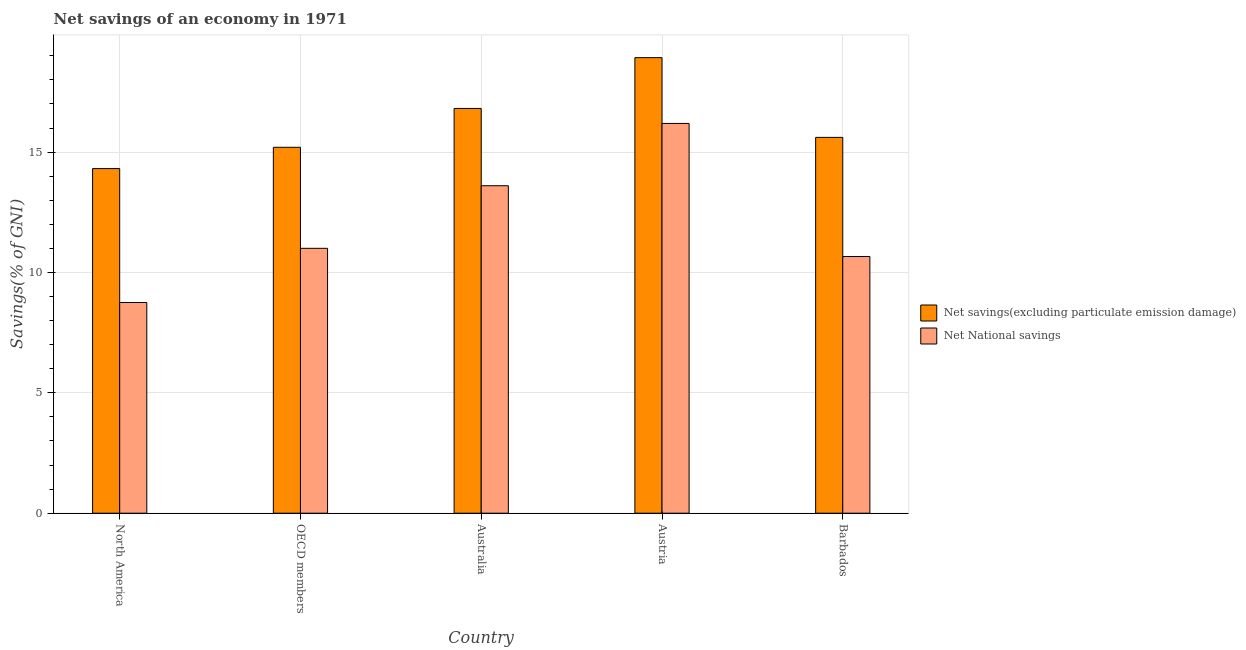How many different coloured bars are there?
Your answer should be very brief. 2. How many bars are there on the 5th tick from the left?
Offer a terse response. 2. How many bars are there on the 3rd tick from the right?
Keep it short and to the point. 2. In how many cases, is the number of bars for a given country not equal to the number of legend labels?
Offer a very short reply. 0. What is the net savings(excluding particulate emission damage) in Austria?
Provide a short and direct response. 18.92. Across all countries, what is the maximum net savings(excluding particulate emission damage)?
Keep it short and to the point. 18.92. Across all countries, what is the minimum net savings(excluding particulate emission damage)?
Your response must be concise. 14.31. In which country was the net savings(excluding particulate emission damage) maximum?
Keep it short and to the point. Austria. What is the total net savings(excluding particulate emission damage) in the graph?
Your answer should be compact. 80.86. What is the difference between the net national savings in Austria and that in Barbados?
Give a very brief answer. 5.53. What is the difference between the net savings(excluding particulate emission damage) in Australia and the net national savings in Barbados?
Offer a terse response. 6.15. What is the average net national savings per country?
Offer a terse response. 12.04. What is the difference between the net national savings and net savings(excluding particulate emission damage) in Austria?
Keep it short and to the point. -2.73. In how many countries, is the net national savings greater than 18 %?
Your answer should be very brief. 0. What is the ratio of the net national savings in Australia to that in OECD members?
Your response must be concise. 1.24. What is the difference between the highest and the second highest net national savings?
Your answer should be compact. 2.59. What is the difference between the highest and the lowest net national savings?
Make the answer very short. 7.44. In how many countries, is the net savings(excluding particulate emission damage) greater than the average net savings(excluding particulate emission damage) taken over all countries?
Your response must be concise. 2. What does the 1st bar from the left in North America represents?
Your response must be concise. Net savings(excluding particulate emission damage). What does the 1st bar from the right in Barbados represents?
Your answer should be compact. Net National savings. How many bars are there?
Your response must be concise. 10. How many countries are there in the graph?
Provide a succinct answer. 5. How are the legend labels stacked?
Offer a terse response. Vertical. What is the title of the graph?
Offer a very short reply. Net savings of an economy in 1971. What is the label or title of the X-axis?
Provide a short and direct response. Country. What is the label or title of the Y-axis?
Provide a short and direct response. Savings(% of GNI). What is the Savings(% of GNI) of Net savings(excluding particulate emission damage) in North America?
Give a very brief answer. 14.31. What is the Savings(% of GNI) of Net National savings in North America?
Ensure brevity in your answer.  8.75. What is the Savings(% of GNI) in Net savings(excluding particulate emission damage) in OECD members?
Keep it short and to the point. 15.2. What is the Savings(% of GNI) in Net National savings in OECD members?
Your response must be concise. 11. What is the Savings(% of GNI) in Net savings(excluding particulate emission damage) in Australia?
Your answer should be very brief. 16.81. What is the Savings(% of GNI) of Net National savings in Australia?
Ensure brevity in your answer.  13.6. What is the Savings(% of GNI) of Net savings(excluding particulate emission damage) in Austria?
Ensure brevity in your answer.  18.92. What is the Savings(% of GNI) in Net National savings in Austria?
Your response must be concise. 16.19. What is the Savings(% of GNI) in Net savings(excluding particulate emission damage) in Barbados?
Your answer should be very brief. 15.61. What is the Savings(% of GNI) of Net National savings in Barbados?
Keep it short and to the point. 10.66. Across all countries, what is the maximum Savings(% of GNI) in Net savings(excluding particulate emission damage)?
Ensure brevity in your answer.  18.92. Across all countries, what is the maximum Savings(% of GNI) of Net National savings?
Offer a very short reply. 16.19. Across all countries, what is the minimum Savings(% of GNI) in Net savings(excluding particulate emission damage)?
Make the answer very short. 14.31. Across all countries, what is the minimum Savings(% of GNI) of Net National savings?
Provide a succinct answer. 8.75. What is the total Savings(% of GNI) in Net savings(excluding particulate emission damage) in the graph?
Your answer should be compact. 80.86. What is the total Savings(% of GNI) of Net National savings in the graph?
Your response must be concise. 60.21. What is the difference between the Savings(% of GNI) of Net savings(excluding particulate emission damage) in North America and that in OECD members?
Provide a short and direct response. -0.88. What is the difference between the Savings(% of GNI) in Net National savings in North America and that in OECD members?
Give a very brief answer. -2.25. What is the difference between the Savings(% of GNI) in Net savings(excluding particulate emission damage) in North America and that in Australia?
Give a very brief answer. -2.5. What is the difference between the Savings(% of GNI) of Net National savings in North America and that in Australia?
Offer a very short reply. -4.85. What is the difference between the Savings(% of GNI) of Net savings(excluding particulate emission damage) in North America and that in Austria?
Provide a short and direct response. -4.61. What is the difference between the Savings(% of GNI) of Net National savings in North America and that in Austria?
Make the answer very short. -7.44. What is the difference between the Savings(% of GNI) in Net savings(excluding particulate emission damage) in North America and that in Barbados?
Offer a terse response. -1.3. What is the difference between the Savings(% of GNI) in Net National savings in North America and that in Barbados?
Make the answer very short. -1.91. What is the difference between the Savings(% of GNI) of Net savings(excluding particulate emission damage) in OECD members and that in Australia?
Keep it short and to the point. -1.61. What is the difference between the Savings(% of GNI) of Net savings(excluding particulate emission damage) in OECD members and that in Austria?
Keep it short and to the point. -3.72. What is the difference between the Savings(% of GNI) of Net National savings in OECD members and that in Austria?
Give a very brief answer. -5.19. What is the difference between the Savings(% of GNI) of Net savings(excluding particulate emission damage) in OECD members and that in Barbados?
Provide a short and direct response. -0.41. What is the difference between the Savings(% of GNI) of Net National savings in OECD members and that in Barbados?
Make the answer very short. 0.34. What is the difference between the Savings(% of GNI) of Net savings(excluding particulate emission damage) in Australia and that in Austria?
Make the answer very short. -2.11. What is the difference between the Savings(% of GNI) in Net National savings in Australia and that in Austria?
Offer a very short reply. -2.59. What is the difference between the Savings(% of GNI) in Net savings(excluding particulate emission damage) in Australia and that in Barbados?
Your answer should be very brief. 1.2. What is the difference between the Savings(% of GNI) in Net National savings in Australia and that in Barbados?
Your answer should be very brief. 2.94. What is the difference between the Savings(% of GNI) in Net savings(excluding particulate emission damage) in Austria and that in Barbados?
Offer a very short reply. 3.31. What is the difference between the Savings(% of GNI) in Net National savings in Austria and that in Barbados?
Your answer should be compact. 5.53. What is the difference between the Savings(% of GNI) in Net savings(excluding particulate emission damage) in North America and the Savings(% of GNI) in Net National savings in OECD members?
Your response must be concise. 3.31. What is the difference between the Savings(% of GNI) in Net savings(excluding particulate emission damage) in North America and the Savings(% of GNI) in Net National savings in Australia?
Your answer should be compact. 0.71. What is the difference between the Savings(% of GNI) in Net savings(excluding particulate emission damage) in North America and the Savings(% of GNI) in Net National savings in Austria?
Your response must be concise. -1.88. What is the difference between the Savings(% of GNI) of Net savings(excluding particulate emission damage) in North America and the Savings(% of GNI) of Net National savings in Barbados?
Your answer should be very brief. 3.65. What is the difference between the Savings(% of GNI) in Net savings(excluding particulate emission damage) in OECD members and the Savings(% of GNI) in Net National savings in Australia?
Keep it short and to the point. 1.6. What is the difference between the Savings(% of GNI) of Net savings(excluding particulate emission damage) in OECD members and the Savings(% of GNI) of Net National savings in Austria?
Give a very brief answer. -0.99. What is the difference between the Savings(% of GNI) of Net savings(excluding particulate emission damage) in OECD members and the Savings(% of GNI) of Net National savings in Barbados?
Your answer should be compact. 4.54. What is the difference between the Savings(% of GNI) in Net savings(excluding particulate emission damage) in Australia and the Savings(% of GNI) in Net National savings in Austria?
Make the answer very short. 0.62. What is the difference between the Savings(% of GNI) of Net savings(excluding particulate emission damage) in Australia and the Savings(% of GNI) of Net National savings in Barbados?
Give a very brief answer. 6.15. What is the difference between the Savings(% of GNI) of Net savings(excluding particulate emission damage) in Austria and the Savings(% of GNI) of Net National savings in Barbados?
Make the answer very short. 8.26. What is the average Savings(% of GNI) in Net savings(excluding particulate emission damage) per country?
Provide a succinct answer. 16.17. What is the average Savings(% of GNI) of Net National savings per country?
Offer a terse response. 12.04. What is the difference between the Savings(% of GNI) in Net savings(excluding particulate emission damage) and Savings(% of GNI) in Net National savings in North America?
Offer a very short reply. 5.56. What is the difference between the Savings(% of GNI) in Net savings(excluding particulate emission damage) and Savings(% of GNI) in Net National savings in OECD members?
Your answer should be compact. 4.2. What is the difference between the Savings(% of GNI) of Net savings(excluding particulate emission damage) and Savings(% of GNI) of Net National savings in Australia?
Your answer should be very brief. 3.21. What is the difference between the Savings(% of GNI) in Net savings(excluding particulate emission damage) and Savings(% of GNI) in Net National savings in Austria?
Your answer should be compact. 2.73. What is the difference between the Savings(% of GNI) of Net savings(excluding particulate emission damage) and Savings(% of GNI) of Net National savings in Barbados?
Make the answer very short. 4.95. What is the ratio of the Savings(% of GNI) of Net savings(excluding particulate emission damage) in North America to that in OECD members?
Offer a terse response. 0.94. What is the ratio of the Savings(% of GNI) of Net National savings in North America to that in OECD members?
Your answer should be compact. 0.8. What is the ratio of the Savings(% of GNI) of Net savings(excluding particulate emission damage) in North America to that in Australia?
Offer a terse response. 0.85. What is the ratio of the Savings(% of GNI) in Net National savings in North America to that in Australia?
Your response must be concise. 0.64. What is the ratio of the Savings(% of GNI) in Net savings(excluding particulate emission damage) in North America to that in Austria?
Provide a short and direct response. 0.76. What is the ratio of the Savings(% of GNI) of Net National savings in North America to that in Austria?
Your response must be concise. 0.54. What is the ratio of the Savings(% of GNI) of Net savings(excluding particulate emission damage) in North America to that in Barbados?
Offer a terse response. 0.92. What is the ratio of the Savings(% of GNI) in Net National savings in North America to that in Barbados?
Offer a very short reply. 0.82. What is the ratio of the Savings(% of GNI) of Net savings(excluding particulate emission damage) in OECD members to that in Australia?
Make the answer very short. 0.9. What is the ratio of the Savings(% of GNI) in Net National savings in OECD members to that in Australia?
Give a very brief answer. 0.81. What is the ratio of the Savings(% of GNI) in Net savings(excluding particulate emission damage) in OECD members to that in Austria?
Your response must be concise. 0.8. What is the ratio of the Savings(% of GNI) of Net National savings in OECD members to that in Austria?
Ensure brevity in your answer.  0.68. What is the ratio of the Savings(% of GNI) in Net savings(excluding particulate emission damage) in OECD members to that in Barbados?
Provide a succinct answer. 0.97. What is the ratio of the Savings(% of GNI) of Net National savings in OECD members to that in Barbados?
Offer a terse response. 1.03. What is the ratio of the Savings(% of GNI) of Net savings(excluding particulate emission damage) in Australia to that in Austria?
Offer a very short reply. 0.89. What is the ratio of the Savings(% of GNI) of Net National savings in Australia to that in Austria?
Give a very brief answer. 0.84. What is the ratio of the Savings(% of GNI) of Net savings(excluding particulate emission damage) in Australia to that in Barbados?
Provide a short and direct response. 1.08. What is the ratio of the Savings(% of GNI) of Net National savings in Australia to that in Barbados?
Your answer should be compact. 1.28. What is the ratio of the Savings(% of GNI) of Net savings(excluding particulate emission damage) in Austria to that in Barbados?
Make the answer very short. 1.21. What is the ratio of the Savings(% of GNI) of Net National savings in Austria to that in Barbados?
Offer a terse response. 1.52. What is the difference between the highest and the second highest Savings(% of GNI) of Net savings(excluding particulate emission damage)?
Ensure brevity in your answer.  2.11. What is the difference between the highest and the second highest Savings(% of GNI) in Net National savings?
Provide a short and direct response. 2.59. What is the difference between the highest and the lowest Savings(% of GNI) in Net savings(excluding particulate emission damage)?
Your response must be concise. 4.61. What is the difference between the highest and the lowest Savings(% of GNI) of Net National savings?
Offer a terse response. 7.44. 